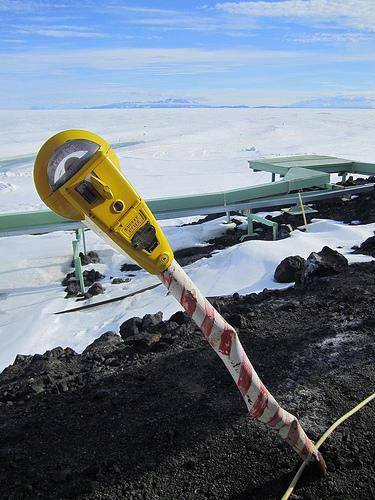Briefly describe the physical condition of the parking meter. The parking meter is bent, broken, and slanted, with a yellow top and a yellow metal knob on the machine. Please describe the main object in the image and its condition. The main object in the image is a yellow parking meter that is bent and mounted on a red and white striped pole with fading paint and dents. How many main objects are there in the image with a size larger than 250x250? There are four main objects with a size larger than 250x250. List three objects with their their respective sizes mentioned in the picture description. The yellow meter has a size of 145x145, the snowy ground has a size of 45x45, and the black gravel has a size of 75x75. Mention one background element and one foreground element in the image. Mountains in the background are one background element and the snow-covered field is one foreground element in the image. What are the main colors mentioned in the image description? Yellow, red, white, black, green, and blue are the main colors mentioned in the image description. What types of objects can be found on the ground in the image? There are snow, twigs, black gravel, and large rocks on the ground in the image. Describe the overall weather conditions in the image. The weather in the image seems to be cold and snowy, with a partially cloudy sky and a frozen lake in the wintertime. Identify the location and environment settings of the image. The image is set in a snowy environment with a frozen lake, mountains in the background, and a snow-covered field with parking meters and a green structure. Which object in the image has the smallest size mentioned in the description? The object with the smallest size mentioned in the description is a large rock in the snow, measuring 18x18. What is the most striking feature of the image? The yellow parking meter in the wintertime Describe the condition of the parking meter and pole. The parking meter is painted yellow, bent, and has a broken top, the pole is red and white striped with dents and fading paint. Describe the scene in a poetic manner. A yellow sentinel stands in snow, with frozen lake and mountains backdrop, a red-striped pole its only companion. Identify the structure with a light green color. The platform List the colors of the sky, ground, and parking meter. Blue sky, black ground, yellow parking meter Which elements in the image suggest that it's a cold place? Snow on the ground, ice-covered mountains, and the frozen lake. Is there any text visible in the image? No What color is the meter? Yellow Describe the emotional state of a person in the image. There is no person in the image. Which elements in the image are man-made? The yellow parking meter, red and white striped pole, and the light green structure. Based on the image, what season is it likely to be? Winter Interpret the image as a metaphor for perseverance. The yellow parking meter, despite being broken and bent, stands tall and strong in the cold snowy landscape, symbolizing resilience and determination. What is the state of the pole with the parking meter? It is bent, with dents and fading paint. What is the main object in the snow? Yellow parking meter Choose the correct description for the pole: (A) Blue and white (B) Red and white (C) Green and white (B) Red and white List any visible damage to the objects in the image. The parking meter is bent, and the pole has dents and fading paint. What type of landscape is shown in the image? A snowy field with mountains What is the weather like in the image? Partially cloudy and snowy Explain the state of the terrain in the image. It is a snowy field with a black gravelly ground, large rocks, and a light green structure. 